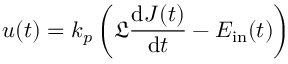<formula> <loc_0><loc_0><loc_500><loc_500>u ( t ) = k _ { p } \left ( \mathfrak { L } \frac { d J ( t ) } { d t } - E _ { i n } ( t ) \right )</formula> 